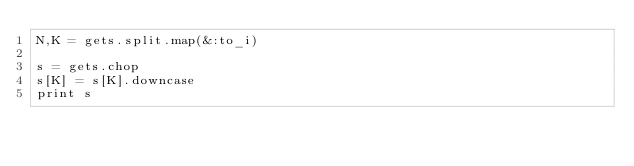<code> <loc_0><loc_0><loc_500><loc_500><_Ruby_>N,K = gets.split.map(&:to_i)

s = gets.chop
s[K] = s[K].downcase
print s</code> 